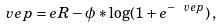Convert formula to latex. <formula><loc_0><loc_0><loc_500><loc_500>\ v e p = e R - \phi * \log ( 1 + e ^ { - \ v e p } ) \, ,</formula> 